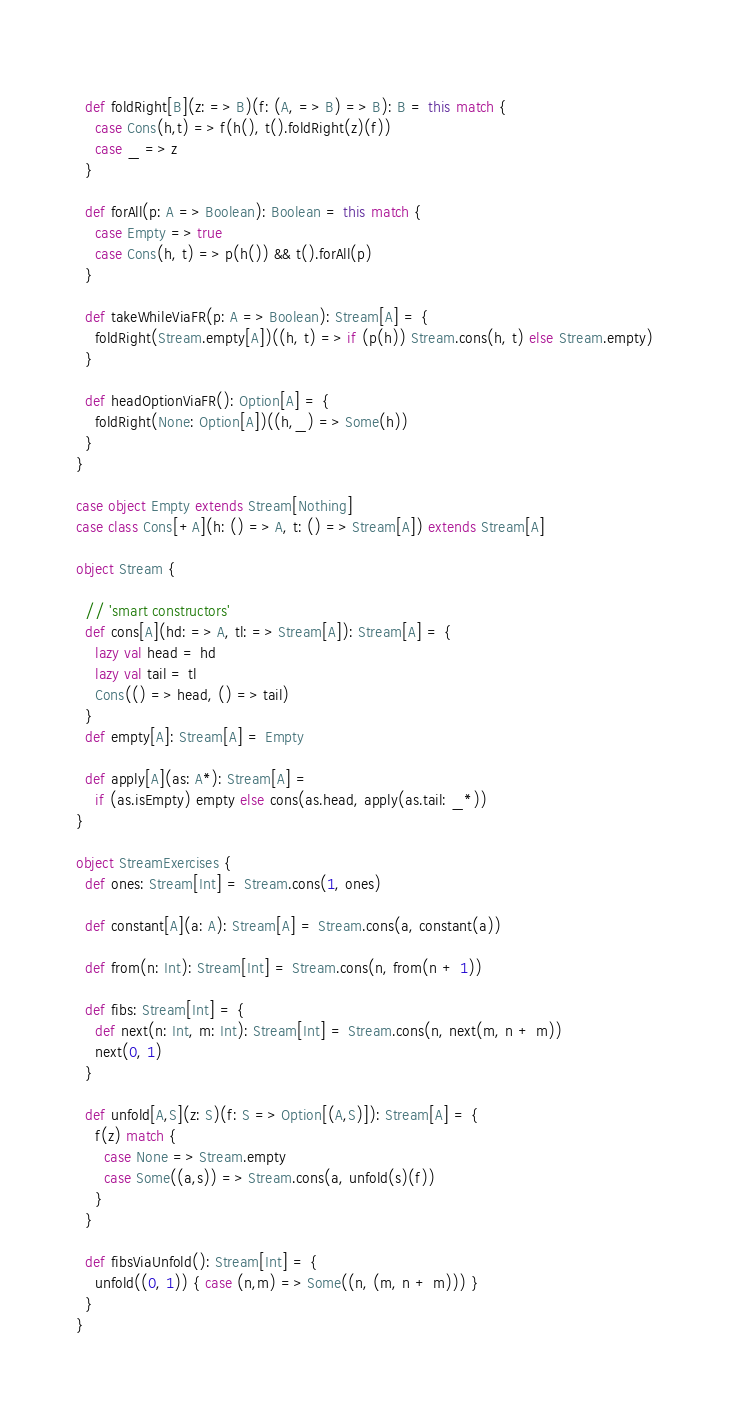Convert code to text. <code><loc_0><loc_0><loc_500><loc_500><_Scala_>  
  def foldRight[B](z: => B)(f: (A, => B) => B): B = this match {
    case Cons(h,t) => f(h(), t().foldRight(z)(f))
    case _ => z
  }
  
  def forAll(p: A => Boolean): Boolean = this match {
    case Empty => true
    case Cons(h, t) => p(h()) && t().forAll(p)
  }
  
  def takeWhileViaFR(p: A => Boolean): Stream[A] = {
    foldRight(Stream.empty[A])((h, t) => if (p(h)) Stream.cons(h, t) else Stream.empty)
  }
  
  def headOptionViaFR(): Option[A] = {
    foldRight(None: Option[A])((h,_) => Some(h))
  }
}

case object Empty extends Stream[Nothing]
case class Cons[+A](h: () => A, t: () => Stream[A]) extends Stream[A]

object Stream {
  
  // 'smart constructors'
  def cons[A](hd: => A, tl: => Stream[A]): Stream[A] = {
    lazy val head = hd
    lazy val tail = tl
    Cons(() => head, () => tail)
  }
  def empty[A]: Stream[A] = Empty
  
  def apply[A](as: A*): Stream[A] =
    if (as.isEmpty) empty else cons(as.head, apply(as.tail: _*))
}

object StreamExercises {
  def ones: Stream[Int] = Stream.cons(1, ones)
  
  def constant[A](a: A): Stream[A] = Stream.cons(a, constant(a))
  
  def from(n: Int): Stream[Int] = Stream.cons(n, from(n + 1))
  
  def fibs: Stream[Int] = {
    def next(n: Int, m: Int): Stream[Int] = Stream.cons(n, next(m, n + m))
    next(0, 1)
  }
  
  def unfold[A,S](z: S)(f: S => Option[(A,S)]): Stream[A] = {
    f(z) match {
      case None => Stream.empty
      case Some((a,s)) => Stream.cons(a, unfold(s)(f))
    }
  }
  
  def fibsViaUnfold(): Stream[Int] = {
    unfold((0, 1)) { case (n,m) => Some((n, (m, n + m))) }
  }
}</code> 